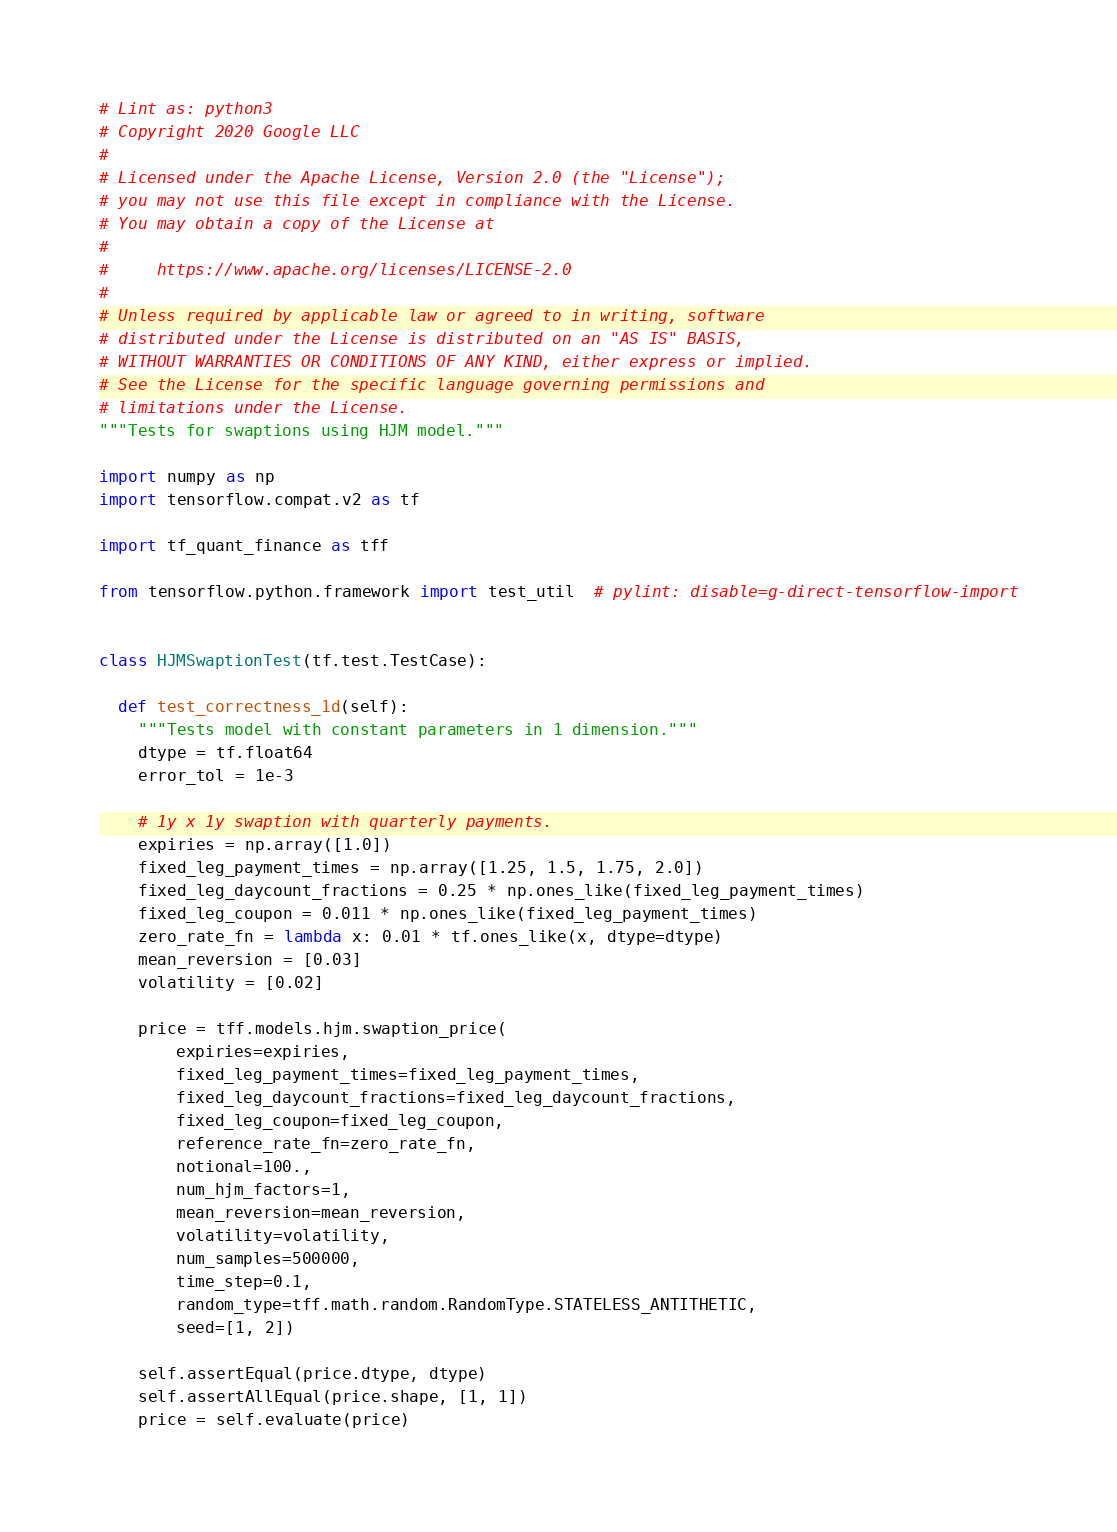<code> <loc_0><loc_0><loc_500><loc_500><_Python_># Lint as: python3
# Copyright 2020 Google LLC
#
# Licensed under the Apache License, Version 2.0 (the "License");
# you may not use this file except in compliance with the License.
# You may obtain a copy of the License at
#
#     https://www.apache.org/licenses/LICENSE-2.0
#
# Unless required by applicable law or agreed to in writing, software
# distributed under the License is distributed on an "AS IS" BASIS,
# WITHOUT WARRANTIES OR CONDITIONS OF ANY KIND, either express or implied.
# See the License for the specific language governing permissions and
# limitations under the License.
"""Tests for swaptions using HJM model."""

import numpy as np
import tensorflow.compat.v2 as tf

import tf_quant_finance as tff

from tensorflow.python.framework import test_util  # pylint: disable=g-direct-tensorflow-import


class HJMSwaptionTest(tf.test.TestCase):

  def test_correctness_1d(self):
    """Tests model with constant parameters in 1 dimension."""
    dtype = tf.float64
    error_tol = 1e-3

    # 1y x 1y swaption with quarterly payments.
    expiries = np.array([1.0])
    fixed_leg_payment_times = np.array([1.25, 1.5, 1.75, 2.0])
    fixed_leg_daycount_fractions = 0.25 * np.ones_like(fixed_leg_payment_times)
    fixed_leg_coupon = 0.011 * np.ones_like(fixed_leg_payment_times)
    zero_rate_fn = lambda x: 0.01 * tf.ones_like(x, dtype=dtype)
    mean_reversion = [0.03]
    volatility = [0.02]

    price = tff.models.hjm.swaption_price(
        expiries=expiries,
        fixed_leg_payment_times=fixed_leg_payment_times,
        fixed_leg_daycount_fractions=fixed_leg_daycount_fractions,
        fixed_leg_coupon=fixed_leg_coupon,
        reference_rate_fn=zero_rate_fn,
        notional=100.,
        num_hjm_factors=1,
        mean_reversion=mean_reversion,
        volatility=volatility,
        num_samples=500000,
        time_step=0.1,
        random_type=tff.math.random.RandomType.STATELESS_ANTITHETIC,
        seed=[1, 2])

    self.assertEqual(price.dtype, dtype)
    self.assertAllEqual(price.shape, [1, 1])
    price = self.evaluate(price)</code> 